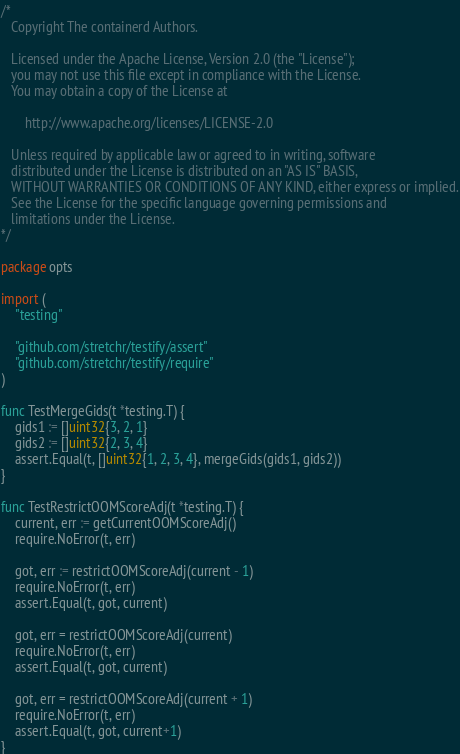<code> <loc_0><loc_0><loc_500><loc_500><_Go_>/*
   Copyright The containerd Authors.

   Licensed under the Apache License, Version 2.0 (the "License");
   you may not use this file except in compliance with the License.
   You may obtain a copy of the License at

       http://www.apache.org/licenses/LICENSE-2.0

   Unless required by applicable law or agreed to in writing, software
   distributed under the License is distributed on an "AS IS" BASIS,
   WITHOUT WARRANTIES OR CONDITIONS OF ANY KIND, either express or implied.
   See the License for the specific language governing permissions and
   limitations under the License.
*/

package opts

import (
	"testing"

	"github.com/stretchr/testify/assert"
	"github.com/stretchr/testify/require"
)

func TestMergeGids(t *testing.T) {
	gids1 := []uint32{3, 2, 1}
	gids2 := []uint32{2, 3, 4}
	assert.Equal(t, []uint32{1, 2, 3, 4}, mergeGids(gids1, gids2))
}

func TestRestrictOOMScoreAdj(t *testing.T) {
	current, err := getCurrentOOMScoreAdj()
	require.NoError(t, err)

	got, err := restrictOOMScoreAdj(current - 1)
	require.NoError(t, err)
	assert.Equal(t, got, current)

	got, err = restrictOOMScoreAdj(current)
	require.NoError(t, err)
	assert.Equal(t, got, current)

	got, err = restrictOOMScoreAdj(current + 1)
	require.NoError(t, err)
	assert.Equal(t, got, current+1)
}
</code> 